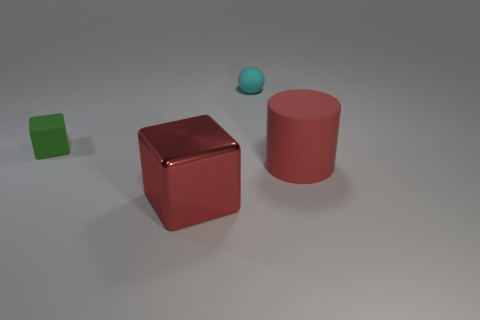Describe the colors of the objects seen in the image. In the image, there are objects with distinct colors: a green cube, a red cylinder, and a blue sphere. Which object appears to be the smallest? The blue sphere appears to be the smallest object in the image. 